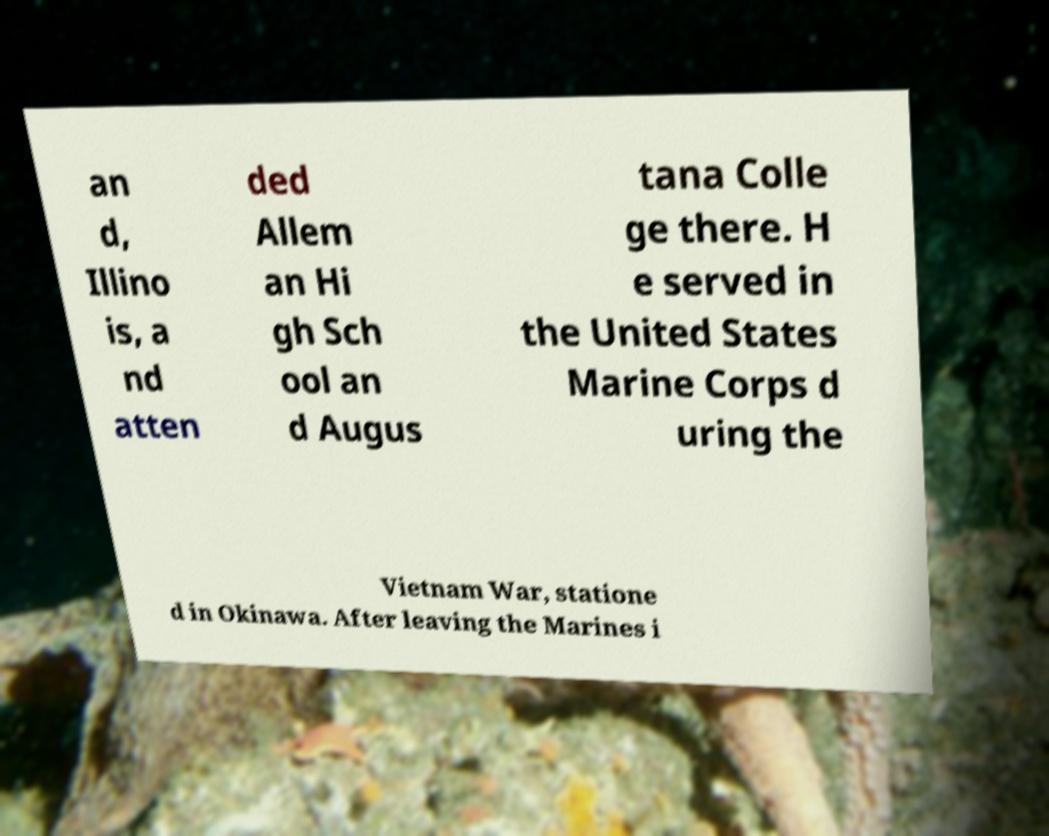I need the written content from this picture converted into text. Can you do that? an d, Illino is, a nd atten ded Allem an Hi gh Sch ool an d Augus tana Colle ge there. H e served in the United States Marine Corps d uring the Vietnam War, statione d in Okinawa. After leaving the Marines i 